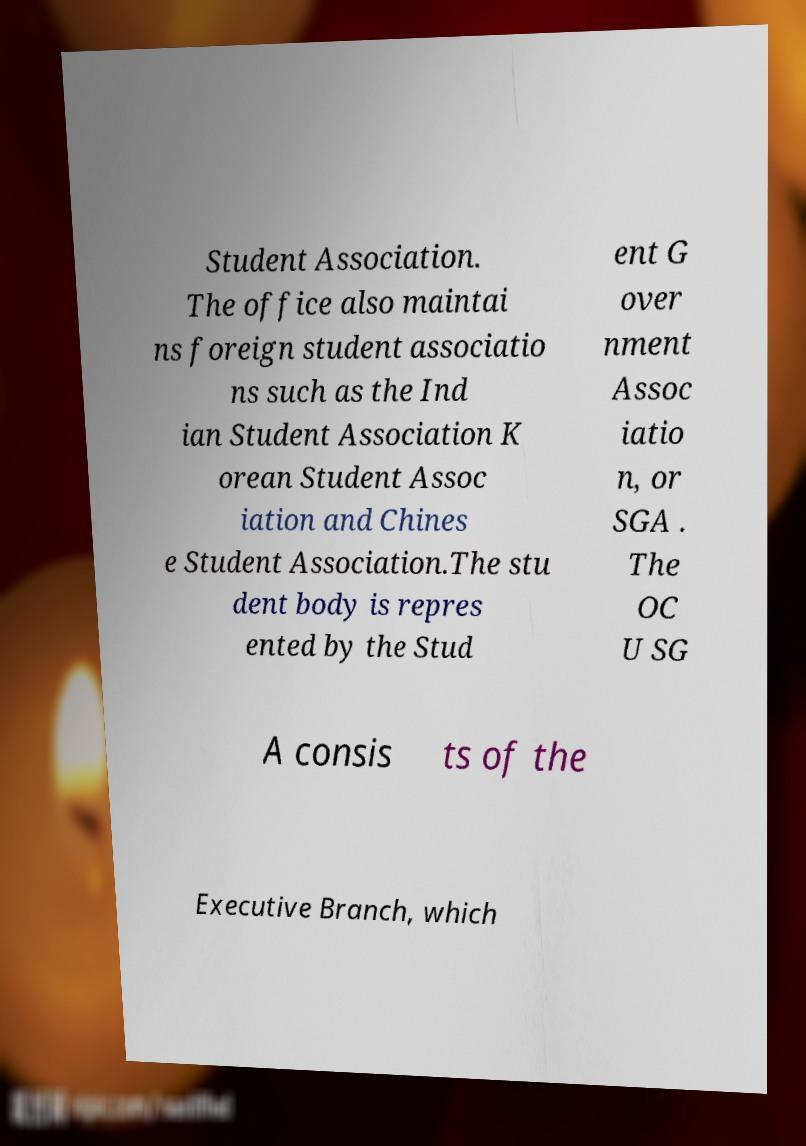Please read and relay the text visible in this image. What does it say? Student Association. The office also maintai ns foreign student associatio ns such as the Ind ian Student Association K orean Student Assoc iation and Chines e Student Association.The stu dent body is repres ented by the Stud ent G over nment Assoc iatio n, or SGA . The OC U SG A consis ts of the Executive Branch, which 